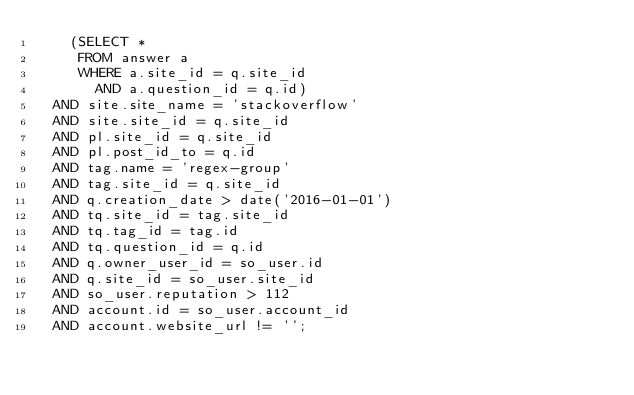<code> <loc_0><loc_0><loc_500><loc_500><_SQL_>    (SELECT *
     FROM answer a
     WHERE a.site_id = q.site_id
       AND a.question_id = q.id)
  AND site.site_name = 'stackoverflow'
  AND site.site_id = q.site_id
  AND pl.site_id = q.site_id
  AND pl.post_id_to = q.id
  AND tag.name = 'regex-group'
  AND tag.site_id = q.site_id
  AND q.creation_date > date('2016-01-01')
  AND tq.site_id = tag.site_id
  AND tq.tag_id = tag.id
  AND tq.question_id = q.id
  AND q.owner_user_id = so_user.id
  AND q.site_id = so_user.site_id
  AND so_user.reputation > 112
  AND account.id = so_user.account_id
  AND account.website_url != '';</code> 